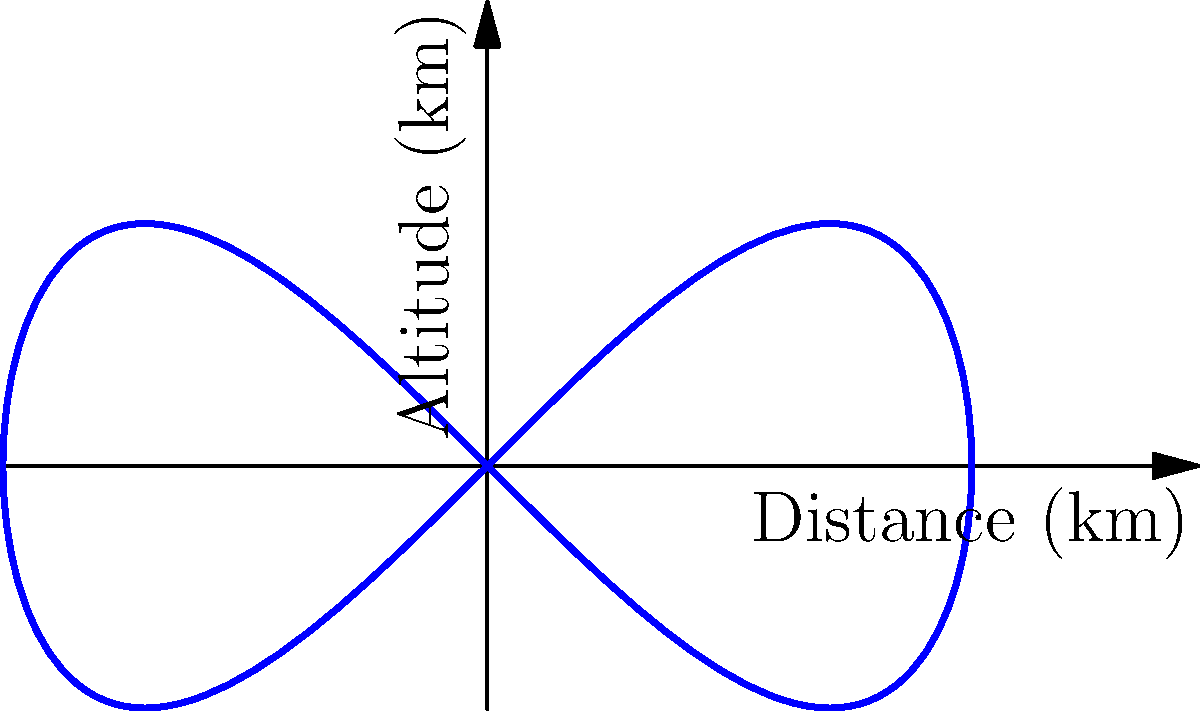The flight trajectory of an aircraft between two cities A and B is represented by the parametric curve:

$x = 100\cos(t)$, $y = 50\sin(2t)$, where $0 \leq t \leq 2\pi$

$x$ represents the horizontal distance in kilometers, and $y$ represents the altitude in kilometers. If the aircraft's fuel consumption is proportional to the length of the trajectory, estimate the total fuel consumption for this flight. Use the approximation that the length of the curve is about 1.1 times the straight-line distance between A and B. To solve this problem, we'll follow these steps:

1) First, we need to find the coordinates of points A and B:
   At $t = 0$: A$(100, 0)$
   At $t = 2\pi$: B$(-100, 0)$

2) Calculate the straight-line distance between A and B:
   $d = \sqrt{(x_B - x_A)^2 + (y_B - y_A)^2}$
   $d = \sqrt{(-100 - 100)^2 + (0 - 0)^2} = \sqrt{40000} = 200$ km

3) Estimate the length of the curve:
   Estimated length $= 1.1 \times 200 = 220$ km

4) The fuel consumption is proportional to this length. If we assume a consumption rate of 1 unit of fuel per km (for simplicity), the total fuel consumption would be 220 units.

Note: In reality, fuel consumption would also depend on factors like altitude, speed, and weather conditions, which are not accounted for in this simplified model.
Answer: 220 units of fuel 